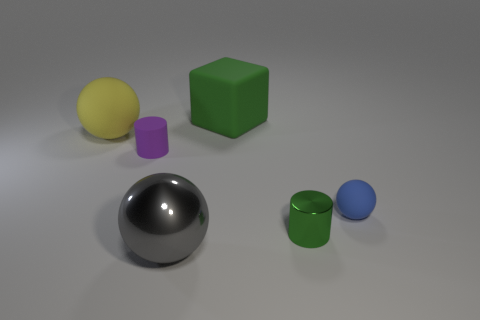Do the metallic thing that is behind the metal ball and the cube have the same color?
Provide a succinct answer. Yes. Are there more tiny objects that are in front of the tiny blue rubber ball than green matte cylinders?
Offer a very short reply. Yes. Is there any other thing that is the same color as the small rubber ball?
Provide a succinct answer. No. The rubber thing that is right of the large green block that is to the left of the small blue object is what shape?
Give a very brief answer. Sphere. Are there more tiny red metallic cylinders than purple things?
Your answer should be very brief. No. What number of objects are left of the green shiny thing and in front of the large matte block?
Provide a succinct answer. 3. There is a big thing that is in front of the yellow matte thing; how many large matte spheres are in front of it?
Your answer should be very brief. 0. What number of objects are either large rubber objects left of the large metal thing or objects that are behind the gray metallic sphere?
Keep it short and to the point. 5. What is the material of the other small object that is the same shape as the small green metallic object?
Your response must be concise. Rubber. What number of things are tiny green objects that are on the right side of the gray metallic thing or small cyan spheres?
Your response must be concise. 1. 